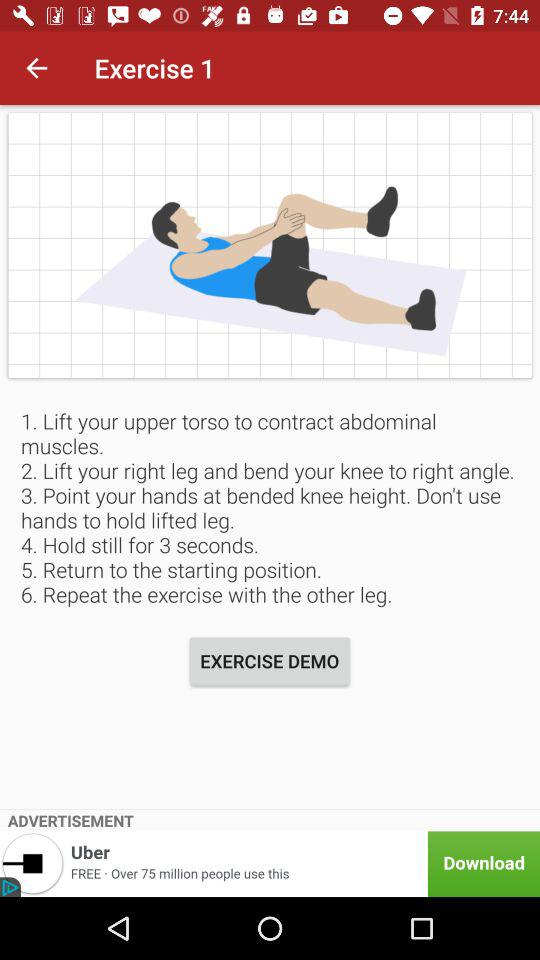How many steps are there in the exercise?
Answer the question using a single word or phrase. 6 